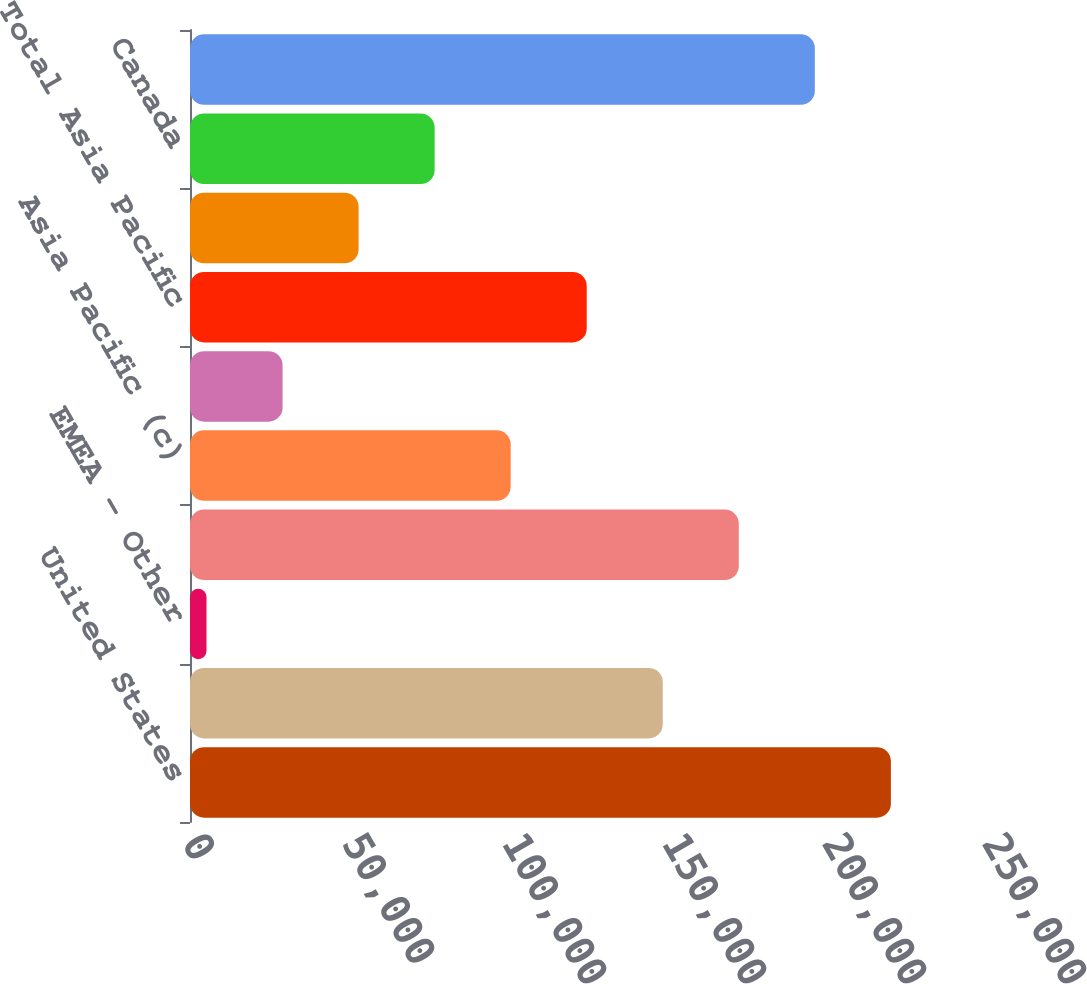Convert chart to OTSL. <chart><loc_0><loc_0><loc_500><loc_500><bar_chart><fcel>United States<fcel>Europe (b)<fcel>EMEA - Other<fcel>Total EMEA<fcel>Asia Pacific (c)<fcel>Asia Pacific - Other<fcel>Total Asia Pacific<fcel>Latin America<fcel>Canada<fcel>Total International Retail<nl><fcel>219025<fcel>147738<fcel>5162<fcel>171500<fcel>100212<fcel>28924.6<fcel>123975<fcel>52687.2<fcel>76449.8<fcel>195263<nl></chart> 